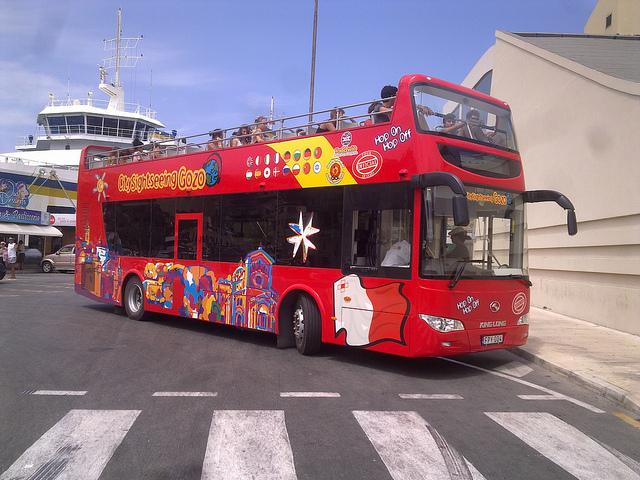What is the name for this type of vehicle? double decker 